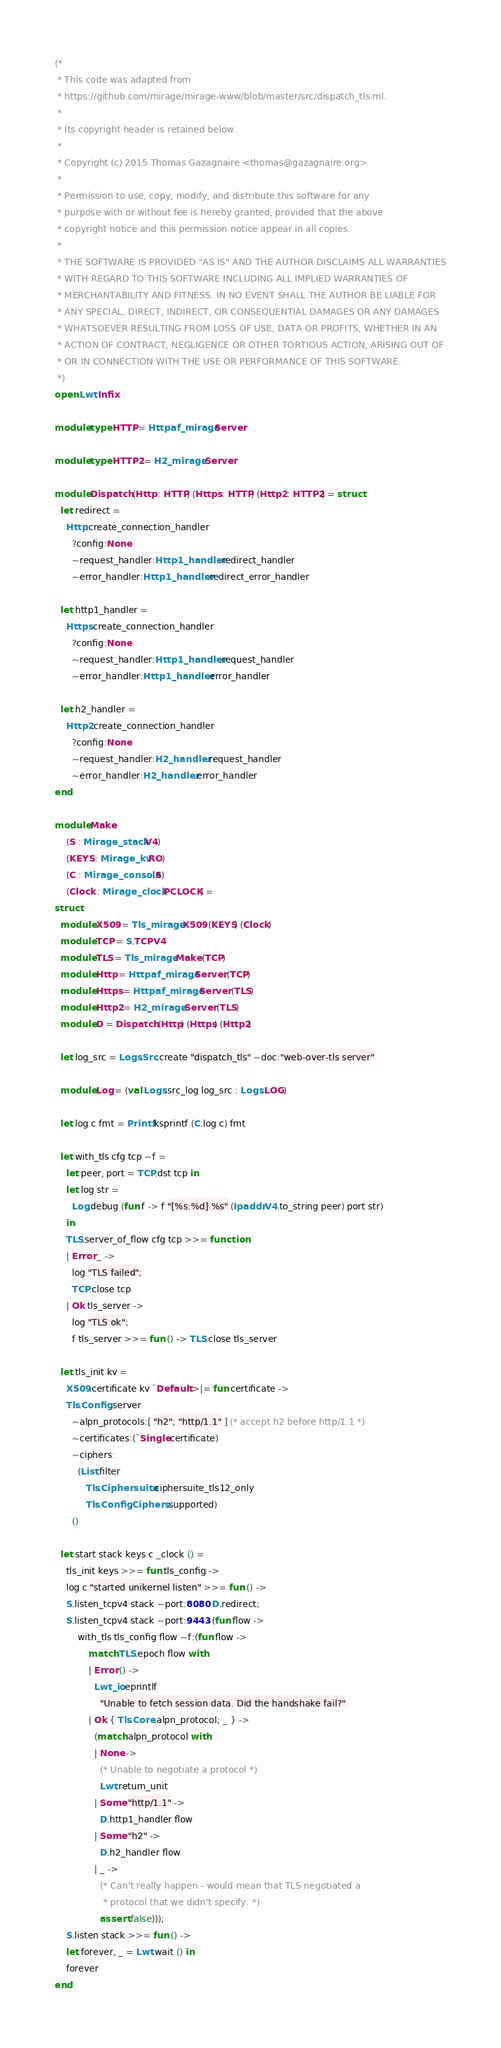<code> <loc_0><loc_0><loc_500><loc_500><_OCaml_>(*
 * This code was adapted from
 * https://github.com/mirage/mirage-www/blob/master/src/dispatch_tls.ml.
 *
 * Its copyright header is retained below.
 *
 * Copyright (c) 2015 Thomas Gazagnaire <thomas@gazagnaire.org>
 *
 * Permission to use, copy, modify, and distribute this software for any
 * purpose with or without fee is hereby granted, provided that the above
 * copyright notice and this permission notice appear in all copies.
 *
 * THE SOFTWARE IS PROVIDED "AS IS" AND THE AUTHOR DISCLAIMS ALL WARRANTIES
 * WITH REGARD TO THIS SOFTWARE INCLUDING ALL IMPLIED WARRANTIES OF
 * MERCHANTABILITY AND FITNESS. IN NO EVENT SHALL THE AUTHOR BE LIABLE FOR
 * ANY SPECIAL, DIRECT, INDIRECT, OR CONSEQUENTIAL DAMAGES OR ANY DAMAGES
 * WHATSOEVER RESULTING FROM LOSS OF USE, DATA OR PROFITS, WHETHER IN AN
 * ACTION OF CONTRACT, NEGLIGENCE OR OTHER TORTIOUS ACTION, ARISING OUT OF
 * OR IN CONNECTION WITH THE USE OR PERFORMANCE OF THIS SOFTWARE.
 *)
open Lwt.Infix

module type HTTP = Httpaf_mirage.Server

module type HTTP2 = H2_mirage.Server

module Dispatch (Http : HTTP) (Https : HTTP) (Http2 : HTTP2) = struct
  let redirect =
    Http.create_connection_handler
      ?config:None
      ~request_handler:Http1_handler.redirect_handler
      ~error_handler:Http1_handler.redirect_error_handler

  let http1_handler =
    Https.create_connection_handler
      ?config:None
      ~request_handler:Http1_handler.request_handler
      ~error_handler:Http1_handler.error_handler

  let h2_handler =
    Http2.create_connection_handler
      ?config:None
      ~request_handler:H2_handler.request_handler
      ~error_handler:H2_handler.error_handler
end

module Make
    (S : Mirage_stack.V4)
    (KEYS : Mirage_kv.RO)
    (C : Mirage_console.S)
    (Clock : Mirage_clock.PCLOCK) =
struct
  module X509 = Tls_mirage.X509 (KEYS) (Clock)
  module TCP = S.TCPV4
  module TLS = Tls_mirage.Make (TCP)
  module Http = Httpaf_mirage.Server (TCP)
  module Https = Httpaf_mirage.Server (TLS)
  module Http2 = H2_mirage.Server (TLS)
  module D = Dispatch (Http) (Https) (Http2)

  let log_src = Logs.Src.create "dispatch_tls" ~doc:"web-over-tls server"

  module Log = (val Logs.src_log log_src : Logs.LOG)

  let log c fmt = Printf.ksprintf (C.log c) fmt

  let with_tls cfg tcp ~f =
    let peer, port = TCP.dst tcp in
    let log str =
      Log.debug (fun f -> f "[%s:%d] %s" (Ipaddr.V4.to_string peer) port str)
    in
    TLS.server_of_flow cfg tcp >>= function
    | Error _ ->
      log "TLS failed";
      TCP.close tcp
    | Ok tls_server ->
      log "TLS ok";
      f tls_server >>= fun () -> TLS.close tls_server

  let tls_init kv =
    X509.certificate kv `Default >|= fun certificate ->
    Tls.Config.server
      ~alpn_protocols:[ "h2"; "http/1.1" ] (* accept h2 before http/1.1 *)
      ~certificates:(`Single certificate)
      ~ciphers:
        (List.filter
           Tls.Ciphersuite.ciphersuite_tls12_only
           Tls.Config.Ciphers.supported)
      ()

  let start stack keys c _clock () =
    tls_init keys >>= fun tls_config ->
    log c "started unikernel listen" >>= fun () ->
    S.listen_tcpv4 stack ~port:8080 D.redirect;
    S.listen_tcpv4 stack ~port:9443 (fun flow ->
        with_tls tls_config flow ~f:(fun flow ->
            match TLS.epoch flow with
            | Error () ->
              Lwt_io.eprintlf
                "Unable to fetch session data. Did the handshake fail?"
            | Ok { Tls.Core.alpn_protocol; _ } ->
              (match alpn_protocol with
              | None ->
                (* Unable to negotiate a protocol *)
                Lwt.return_unit
              | Some "http/1.1" ->
                D.http1_handler flow
              | Some "h2" ->
                D.h2_handler flow
              | _ ->
                (* Can't really happen - would mean that TLS negotiated a
                 * protocol that we didn't specify. *)
                assert false)));
    S.listen stack >>= fun () ->
    let forever, _ = Lwt.wait () in
    forever
end
</code> 